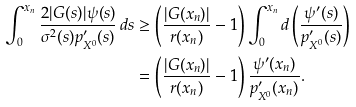<formula> <loc_0><loc_0><loc_500><loc_500>\int _ { 0 } ^ { x _ { n } } \frac { 2 | G ( s ) | \psi ( s ) } { \sigma ^ { 2 } ( s ) p _ { X ^ { 0 } } ^ { \prime } ( s ) } \, d s & \geq \left ( \frac { | G ( x _ { n } ) | } { r ( x _ { n } ) } - 1 \right ) \int _ { 0 } ^ { x _ { n } } d \left ( \frac { \psi ^ { \prime } ( s ) } { p _ { X ^ { 0 } } ^ { \prime } ( s ) } \right ) \\ & = \left ( \frac { | G ( x _ { n } ) | } { r ( x _ { n } ) } - 1 \right ) \frac { \psi ^ { \prime } ( x _ { n } ) } { p _ { X ^ { 0 } } ^ { \prime } ( x _ { n } ) } .</formula> 